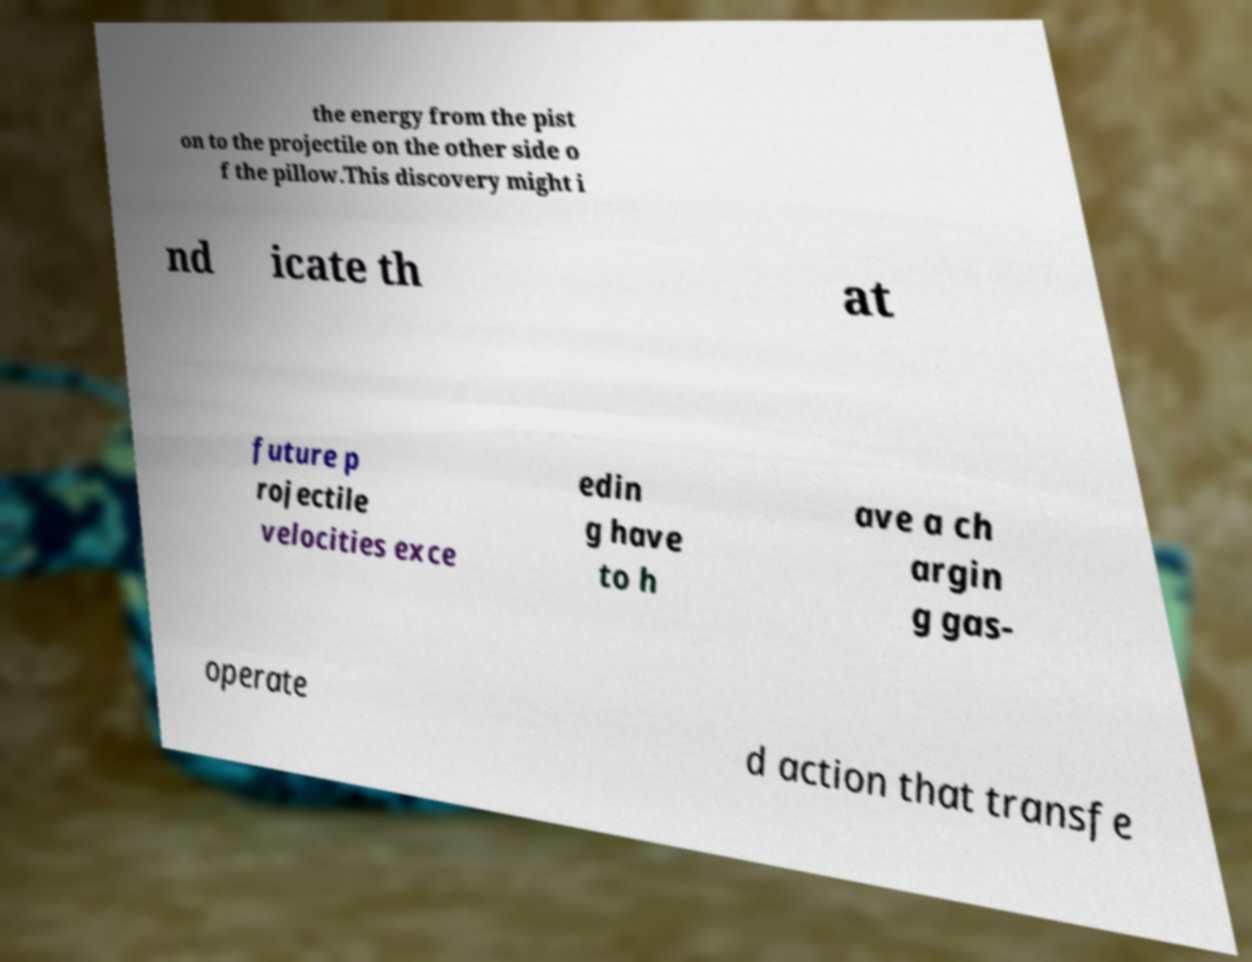Can you read and provide the text displayed in the image?This photo seems to have some interesting text. Can you extract and type it out for me? the energy from the pist on to the projectile on the other side o f the pillow.This discovery might i nd icate th at future p rojectile velocities exce edin g have to h ave a ch argin g gas- operate d action that transfe 